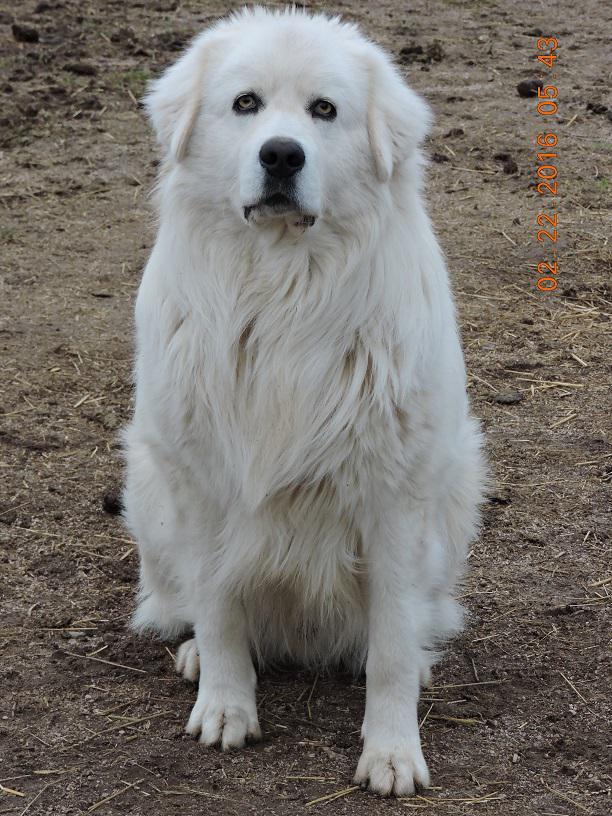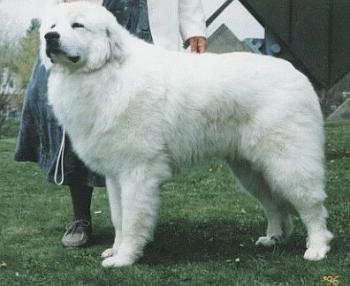The first image is the image on the left, the second image is the image on the right. Analyze the images presented: Is the assertion "at least one dog is on a grass surface" valid? Answer yes or no. Yes. The first image is the image on the left, the second image is the image on the right. For the images shown, is this caption "One dog's mouth is open." true? Answer yes or no. No. 